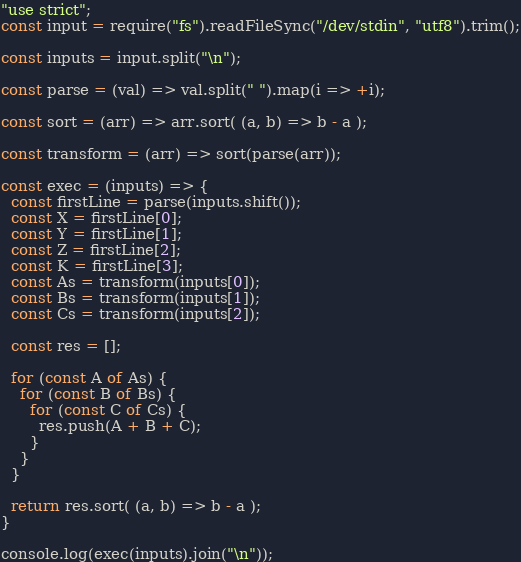Convert code to text. <code><loc_0><loc_0><loc_500><loc_500><_JavaScript_>"use strict";
const input = require("fs").readFileSync("/dev/stdin", "utf8").trim();

const inputs = input.split("\n");

const parse = (val) => val.split(" ").map(i => +i);

const sort = (arr) => arr.sort( (a, b) => b - a );

const transform = (arr) => sort(parse(arr));

const exec = (inputs) => {
  const firstLine = parse(inputs.shift());
  const X = firstLine[0];
  const Y = firstLine[1];
  const Z = firstLine[2];
  const K = firstLine[3];
  const As = transform(inputs[0]);
  const Bs = transform(inputs[1]);
  const Cs = transform(inputs[2]);

  const res = [];

  for (const A of As) {
    for (const B of Bs) {
      for (const C of Cs) {
        res.push(A + B + C);
      }
    }
  }

  return res.sort( (a, b) => b - a );
}

console.log(exec(inputs).join("\n"));</code> 